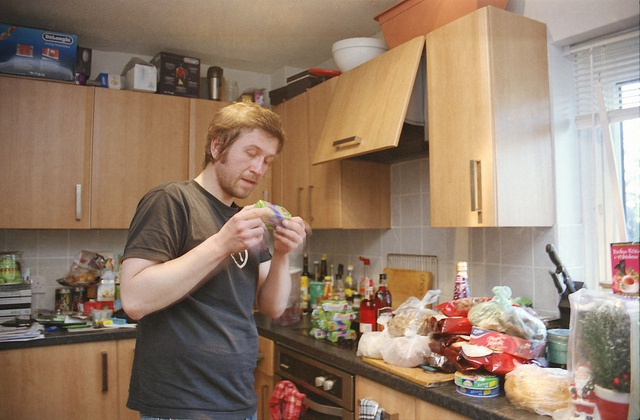Describe the objects in this image and their specific colors. I can see people in black, gray, and tan tones, potted plant in black, gray, and darkgray tones, oven in black, maroon, and gray tones, bowl in black, darkgray, and gray tones, and bottle in black, brown, maroon, gray, and tan tones in this image. 